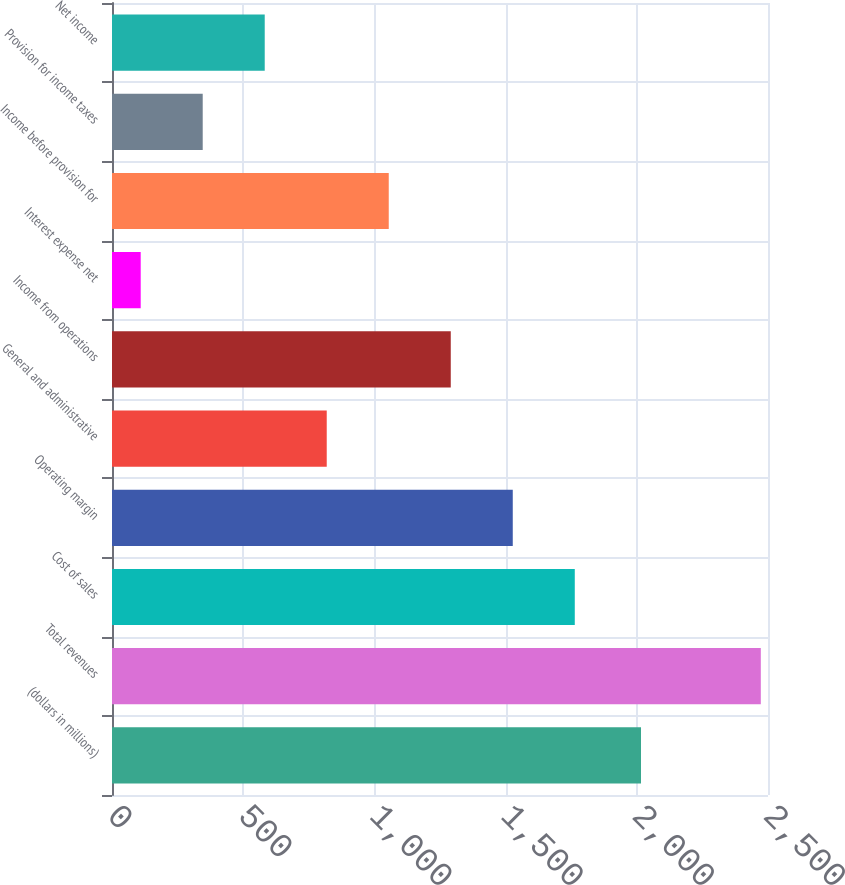Convert chart to OTSL. <chart><loc_0><loc_0><loc_500><loc_500><bar_chart><fcel>(dollars in millions)<fcel>Total revenues<fcel>Cost of sales<fcel>Operating margin<fcel>General and administrative<fcel>Income from operations<fcel>Interest expense net<fcel>Income before provision for<fcel>Provision for income taxes<fcel>Net income<nl><fcel>2016<fcel>2472.6<fcel>1763.64<fcel>1527.32<fcel>818.36<fcel>1291<fcel>109.4<fcel>1054.68<fcel>345.72<fcel>582.04<nl></chart> 